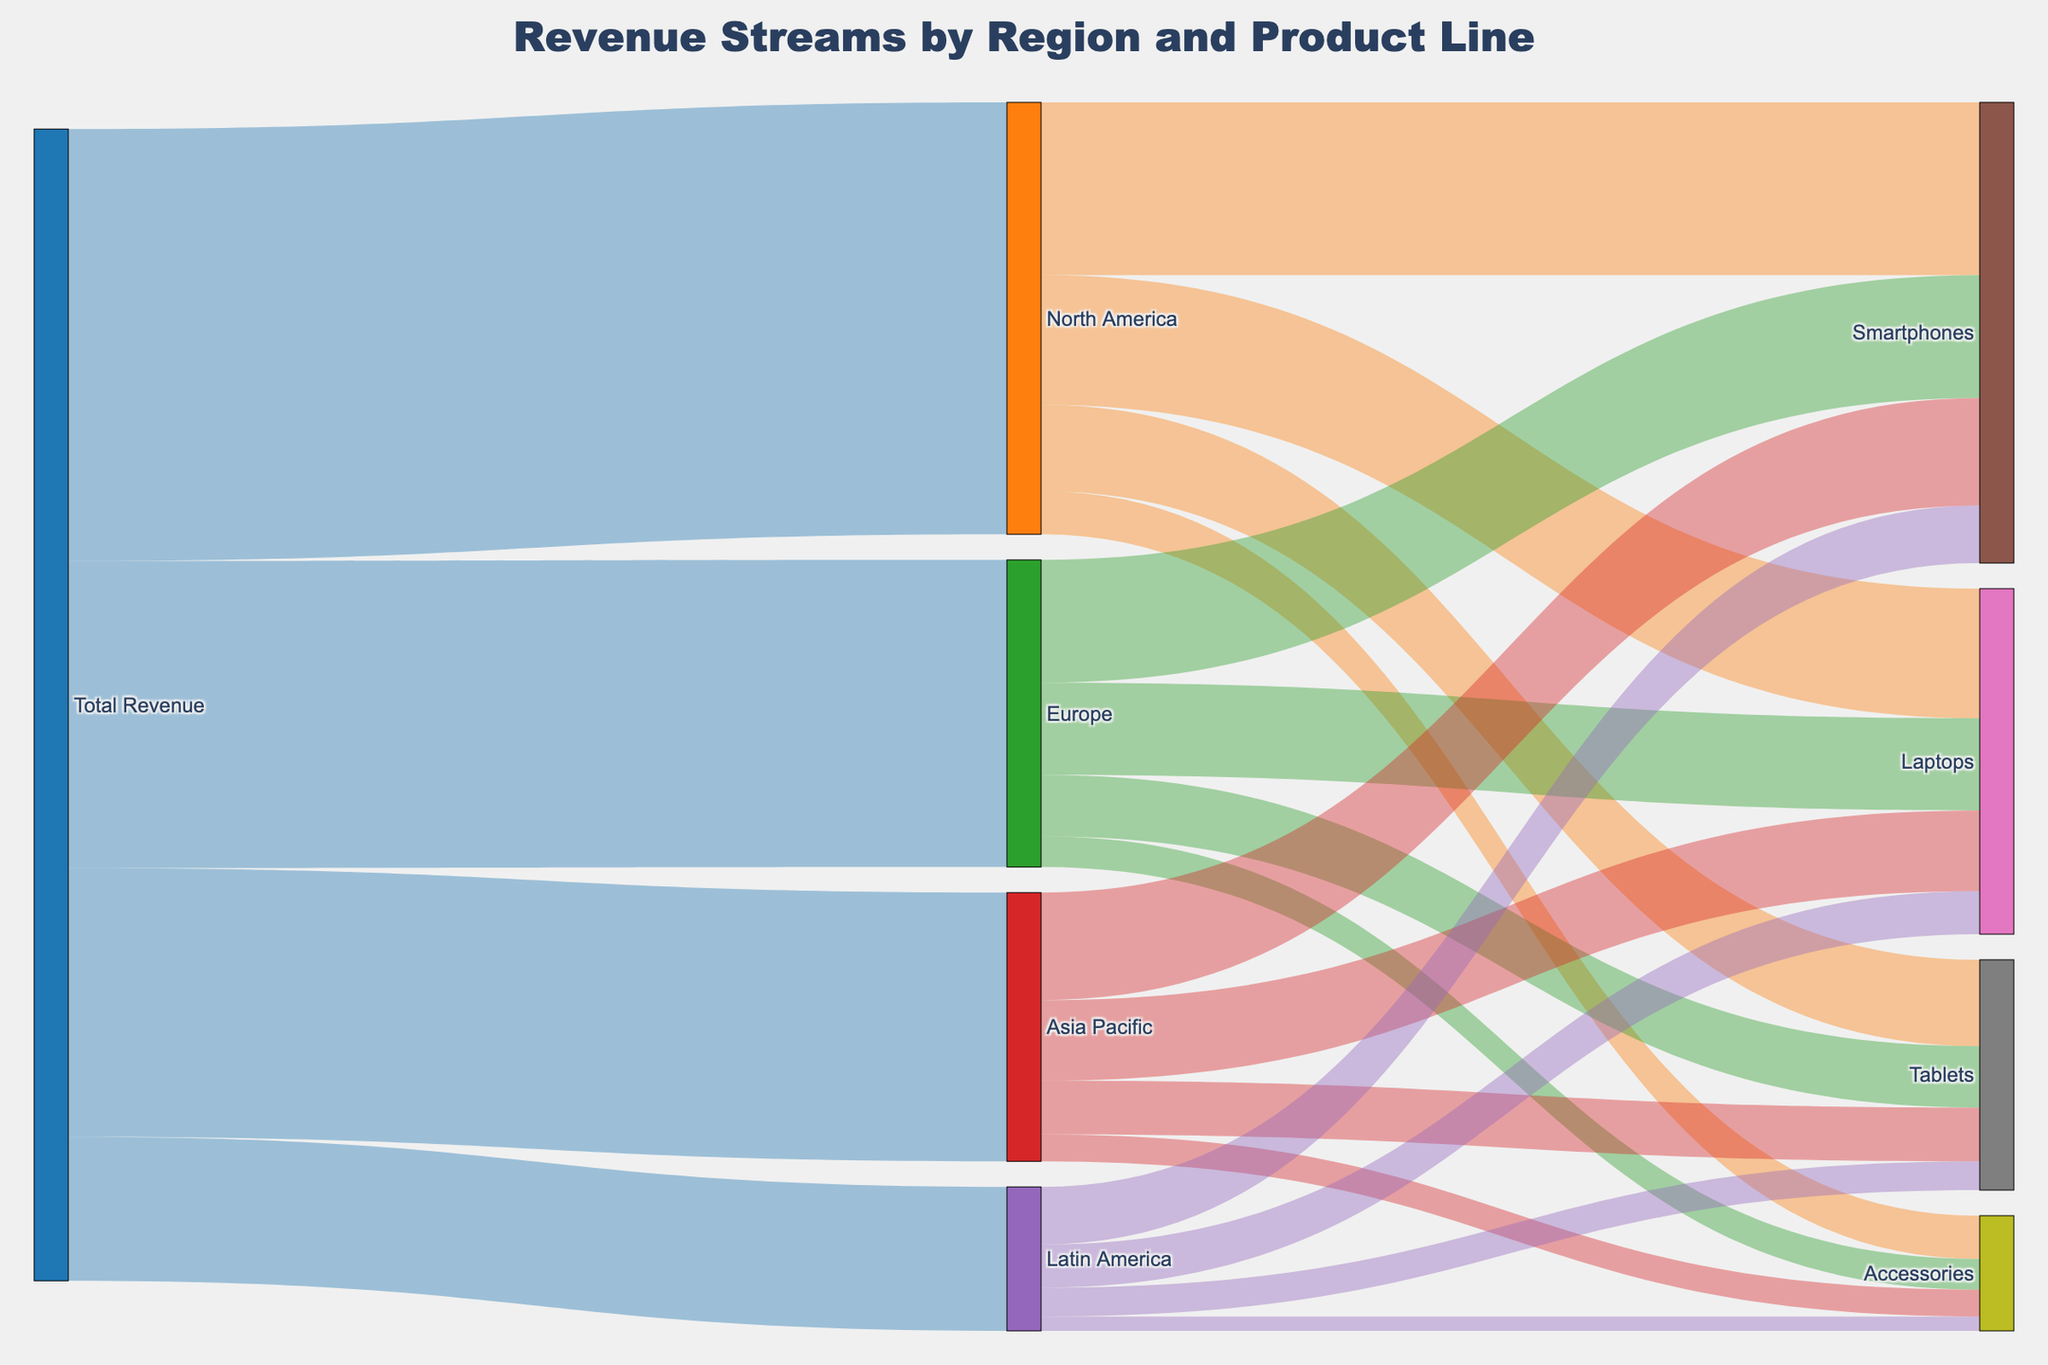What is the title of the Sankey diagram? The title of the Sankey diagram is typically displayed at the top of the figure. It will reflect the main subject of the visualization, which in this case is "Revenue Streams by Region and Product Line".
Answer: Revenue Streams by Region and Product Line Which geographical region contributes the most to the total revenue? To find which geographical region contributes the most, look at the branches coming out from "Total Revenue" and compare their values. North America has the highest value among all regions.
Answer: North America What is the total revenue contributed by Smartphones across all regions? To find the total revenue from Smartphones, add the values of Smartphones from each region: 180000000 (North America) + 128000000 (Europe) + 112000000 (Asia Pacific) + 60000000 (Latin America). This summing process is straightforward arithmetic.
Answer: 480000000 Which product line has the least revenue contribution in Latin America and what is its value? Find the branches stemming from "Latin America" and look for the smallest value. Accessories under Latin America has the smallest value of 15000000.
Answer: Accessories, 15000000 How does the revenue from Laptops in North America compare to that in Asia Pacific? Compare the branches from "North America" and "Asia Pacific" that go to "Laptops". North America's Laptops revenue is 135000000, while Asia Pacific's is 84000000.
Answer: North America’s Laptop revenue is higher What percentage of Europe's total revenue is generated from Smartphones? To determine this, divide the Smartphones revenue from Europe by the total revenue from Europe and multiply by 100: (128000000 / 320000000) * 100. The resulting value represents the percentage.
Answer: 40% Which product line has the highest overall revenue across the regions, and what is the combined revenue? Summarize the revenue from each product line across all regions and compare the totals. Smartphones have the highest combined value: 180000000 + 128000000 + 112000000 + 60000000.
Answer: Smartphones, 480000000 What's the total revenue generated by Accessories across all regions? Add up the revenue values for Accessories from each region: 45000000 (North America) + 32000000 (Europe) + 28000000 (Asia Pacific) + 15000000 (Latin America).
Answer: 120000000 If we exclude North America, what is the total revenue generated by Tablets from the other regions? Add the revenue of Tablets from each region except North America: 64000000 (Europe) + 56000000 (Asia Pacific) + 30000000 (Latin America).
Answer: 150000000 